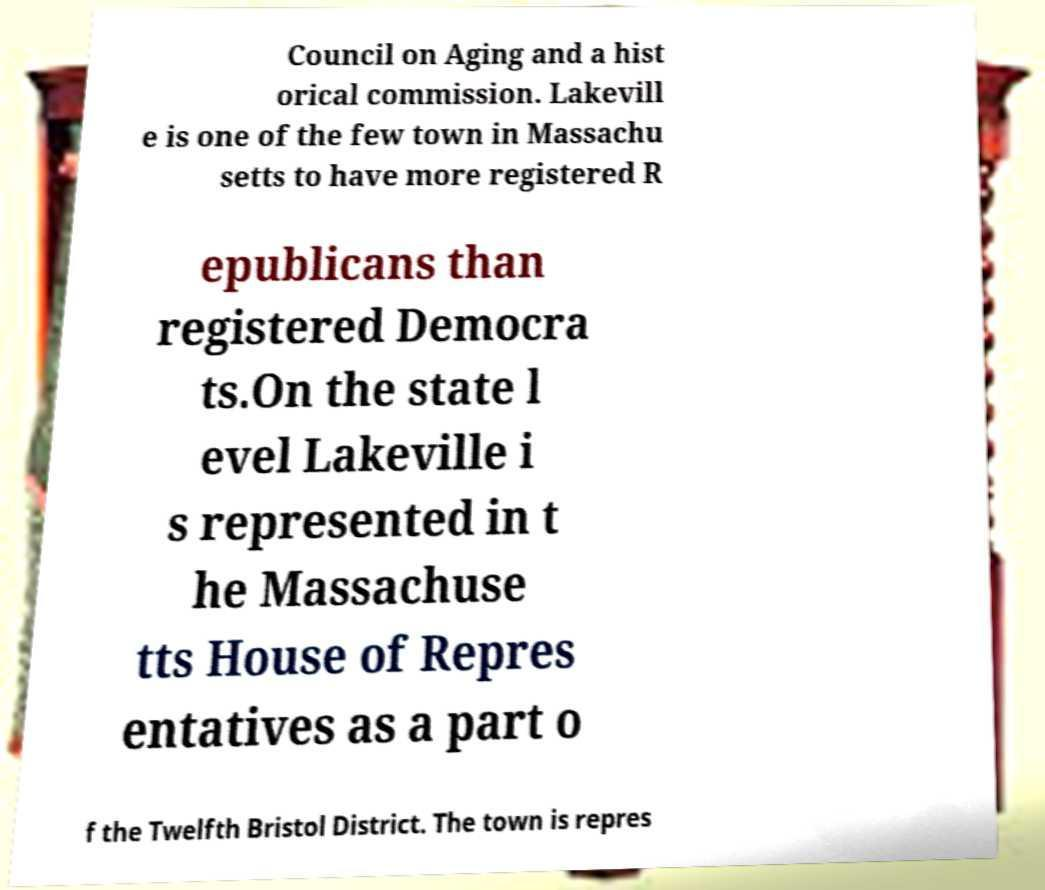Can you read and provide the text displayed in the image?This photo seems to have some interesting text. Can you extract and type it out for me? Council on Aging and a hist orical commission. Lakevill e is one of the few town in Massachu setts to have more registered R epublicans than registered Democra ts.On the state l evel Lakeville i s represented in t he Massachuse tts House of Repres entatives as a part o f the Twelfth Bristol District. The town is repres 